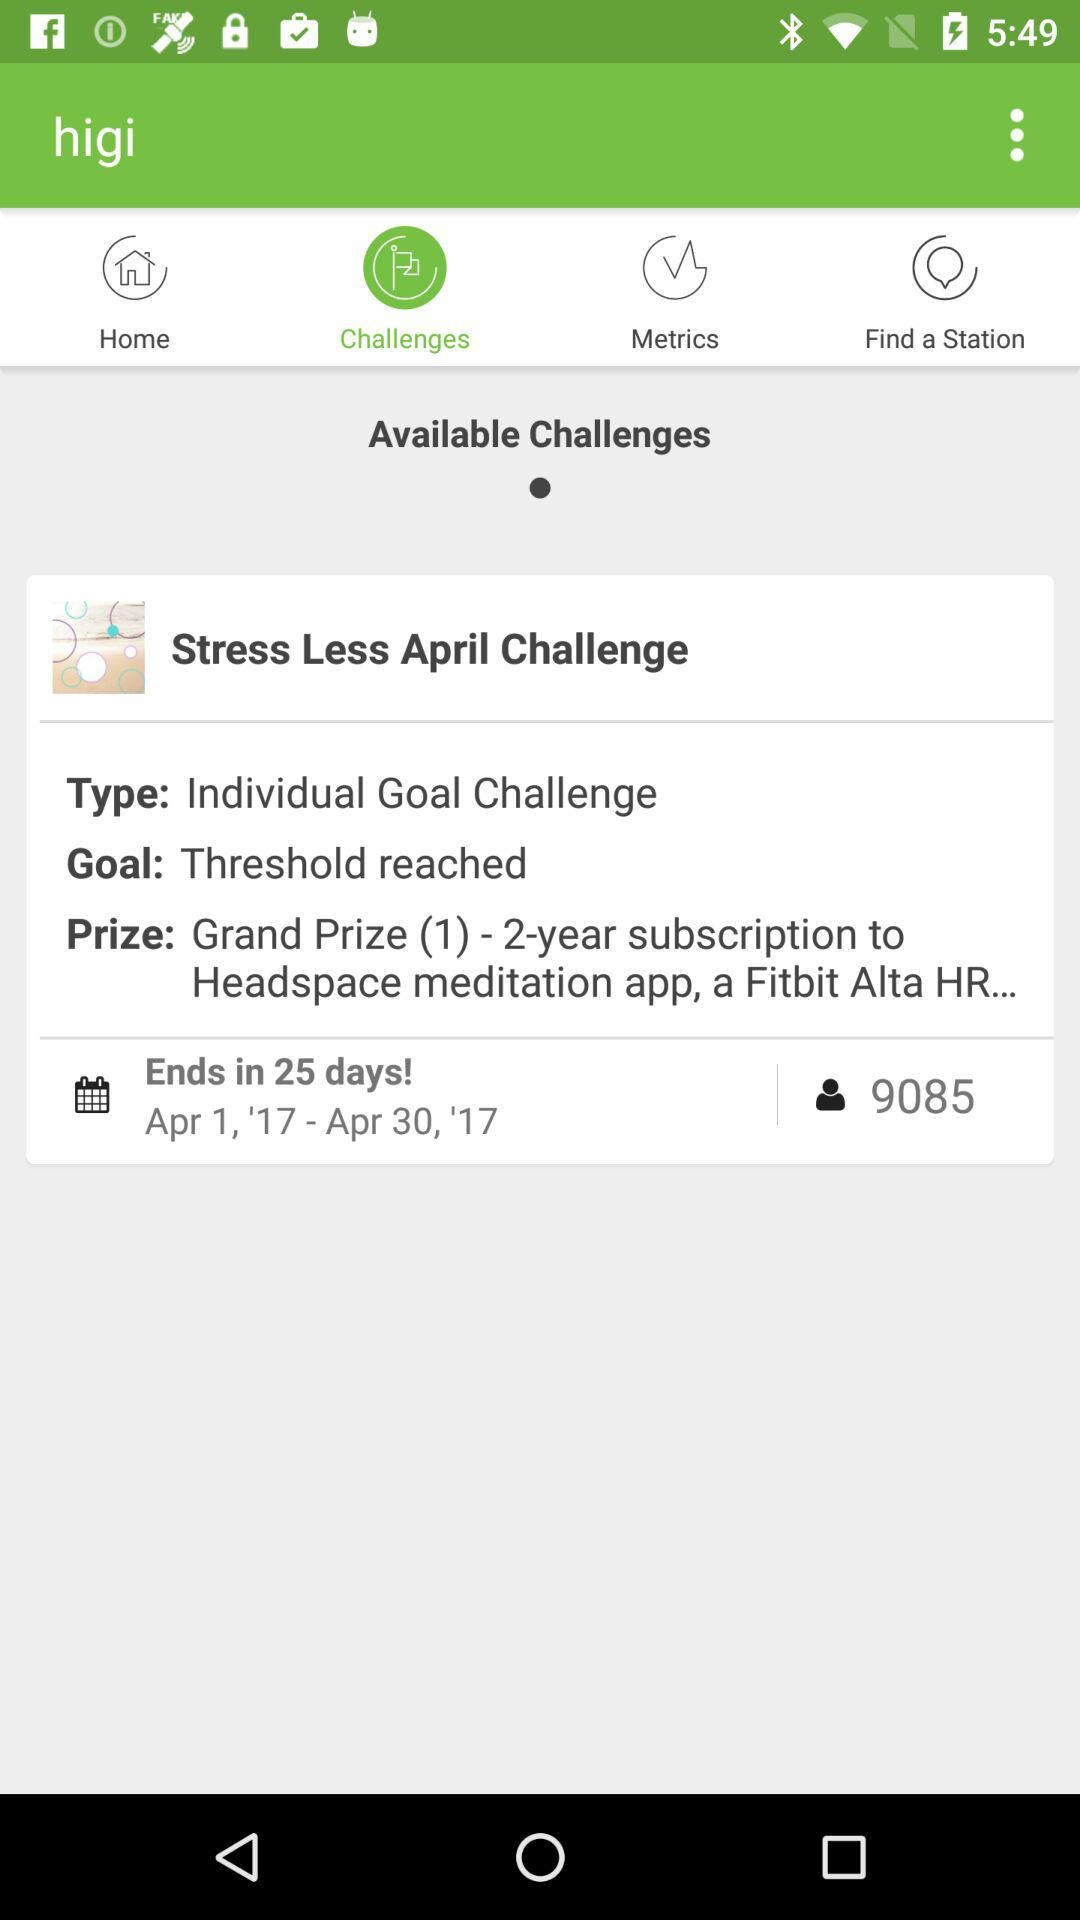When will the challenge end? The challenge will end in 25 days. 